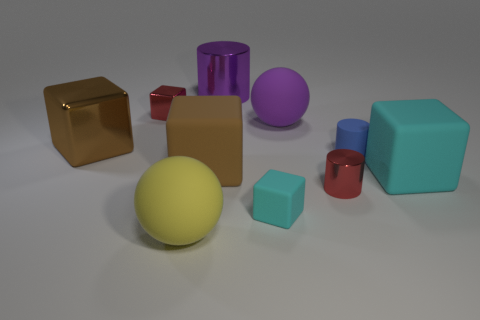There is another sphere that is the same size as the purple ball; what material is it?
Ensure brevity in your answer.  Rubber. There is a small red cylinder that is behind the cyan object on the left side of the red cylinder; what is it made of?
Offer a very short reply. Metal. There is a big purple object that is behind the large purple sphere; is it the same shape as the purple rubber thing?
Give a very brief answer. No. What is the color of the other cylinder that is the same material as the large cylinder?
Offer a terse response. Red. What material is the sphere that is right of the purple metallic thing?
Ensure brevity in your answer.  Rubber. There is a brown metallic thing; is it the same shape as the small red thing that is to the right of the large purple cylinder?
Your answer should be very brief. No. What material is the large block that is left of the blue thing and to the right of the large brown metal block?
Provide a short and direct response. Rubber. The shiny cube that is the same size as the purple matte ball is what color?
Your answer should be compact. Brown. Does the big purple ball have the same material as the tiny thing that is behind the blue object?
Provide a succinct answer. No. How many other objects are the same size as the yellow matte sphere?
Give a very brief answer. 5. 